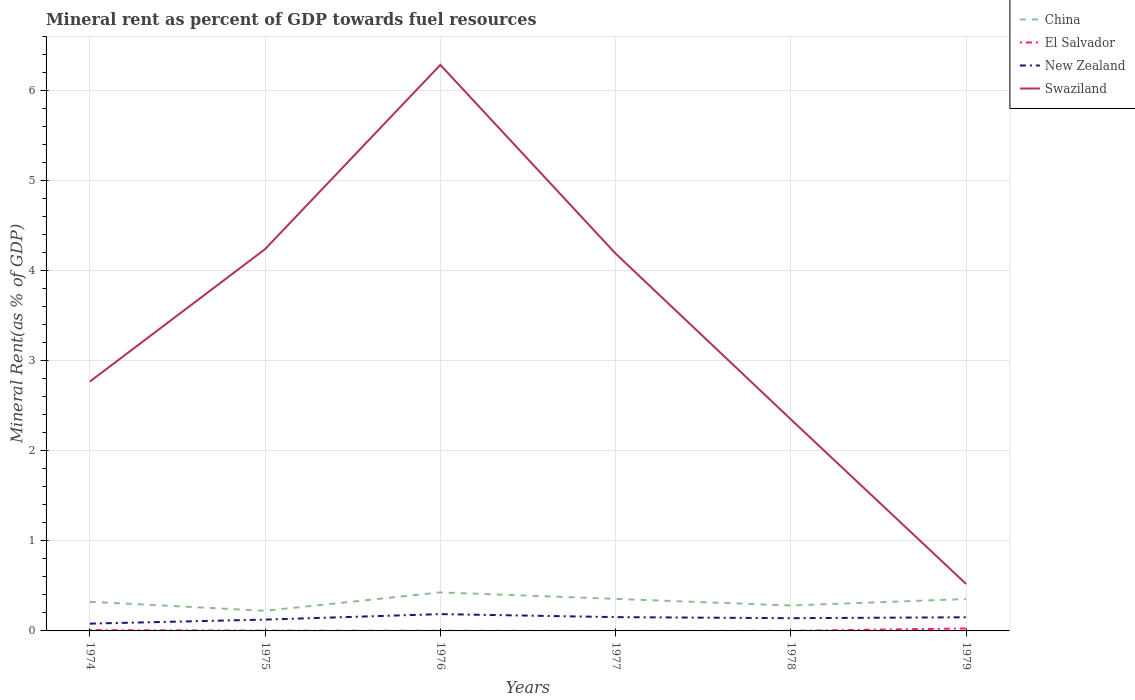How many different coloured lines are there?
Ensure brevity in your answer.  4. Is the number of lines equal to the number of legend labels?
Keep it short and to the point. Yes. Across all years, what is the maximum mineral rent in El Salvador?
Your response must be concise. 0. In which year was the mineral rent in New Zealand maximum?
Offer a terse response. 1974. What is the total mineral rent in El Salvador in the graph?
Your answer should be compact. 0.01. What is the difference between the highest and the second highest mineral rent in New Zealand?
Make the answer very short. 0.11. What is the difference between the highest and the lowest mineral rent in New Zealand?
Your answer should be compact. 4. How many lines are there?
Your response must be concise. 4. How many years are there in the graph?
Provide a succinct answer. 6. What is the difference between two consecutive major ticks on the Y-axis?
Provide a short and direct response. 1. Does the graph contain any zero values?
Your response must be concise. No. Does the graph contain grids?
Make the answer very short. Yes. What is the title of the graph?
Offer a very short reply. Mineral rent as percent of GDP towards fuel resources. Does "Latvia" appear as one of the legend labels in the graph?
Your answer should be very brief. No. What is the label or title of the Y-axis?
Give a very brief answer. Mineral Rent(as % of GDP). What is the Mineral Rent(as % of GDP) of China in 1974?
Offer a very short reply. 0.32. What is the Mineral Rent(as % of GDP) in El Salvador in 1974?
Offer a terse response. 0.01. What is the Mineral Rent(as % of GDP) of New Zealand in 1974?
Offer a terse response. 0.08. What is the Mineral Rent(as % of GDP) in Swaziland in 1974?
Ensure brevity in your answer.  2.77. What is the Mineral Rent(as % of GDP) of China in 1975?
Your answer should be very brief. 0.22. What is the Mineral Rent(as % of GDP) of El Salvador in 1975?
Give a very brief answer. 0. What is the Mineral Rent(as % of GDP) of New Zealand in 1975?
Your answer should be compact. 0.13. What is the Mineral Rent(as % of GDP) of Swaziland in 1975?
Offer a terse response. 4.24. What is the Mineral Rent(as % of GDP) of China in 1976?
Offer a terse response. 0.43. What is the Mineral Rent(as % of GDP) of El Salvador in 1976?
Provide a short and direct response. 0. What is the Mineral Rent(as % of GDP) of New Zealand in 1976?
Provide a short and direct response. 0.19. What is the Mineral Rent(as % of GDP) of Swaziland in 1976?
Provide a succinct answer. 6.29. What is the Mineral Rent(as % of GDP) in China in 1977?
Your answer should be very brief. 0.36. What is the Mineral Rent(as % of GDP) in El Salvador in 1977?
Provide a succinct answer. 0. What is the Mineral Rent(as % of GDP) of New Zealand in 1977?
Your answer should be very brief. 0.15. What is the Mineral Rent(as % of GDP) of Swaziland in 1977?
Keep it short and to the point. 4.19. What is the Mineral Rent(as % of GDP) of China in 1978?
Provide a succinct answer. 0.28. What is the Mineral Rent(as % of GDP) of El Salvador in 1978?
Offer a very short reply. 0. What is the Mineral Rent(as % of GDP) in New Zealand in 1978?
Make the answer very short. 0.14. What is the Mineral Rent(as % of GDP) of Swaziland in 1978?
Your answer should be very brief. 2.35. What is the Mineral Rent(as % of GDP) in China in 1979?
Offer a terse response. 0.35. What is the Mineral Rent(as % of GDP) in El Salvador in 1979?
Your answer should be compact. 0.03. What is the Mineral Rent(as % of GDP) in New Zealand in 1979?
Keep it short and to the point. 0.15. What is the Mineral Rent(as % of GDP) in Swaziland in 1979?
Ensure brevity in your answer.  0.52. Across all years, what is the maximum Mineral Rent(as % of GDP) in China?
Make the answer very short. 0.43. Across all years, what is the maximum Mineral Rent(as % of GDP) in El Salvador?
Make the answer very short. 0.03. Across all years, what is the maximum Mineral Rent(as % of GDP) in New Zealand?
Your response must be concise. 0.19. Across all years, what is the maximum Mineral Rent(as % of GDP) in Swaziland?
Ensure brevity in your answer.  6.29. Across all years, what is the minimum Mineral Rent(as % of GDP) in China?
Keep it short and to the point. 0.22. Across all years, what is the minimum Mineral Rent(as % of GDP) in El Salvador?
Provide a succinct answer. 0. Across all years, what is the minimum Mineral Rent(as % of GDP) of New Zealand?
Ensure brevity in your answer.  0.08. Across all years, what is the minimum Mineral Rent(as % of GDP) of Swaziland?
Make the answer very short. 0.52. What is the total Mineral Rent(as % of GDP) in China in the graph?
Your answer should be very brief. 1.97. What is the total Mineral Rent(as % of GDP) of El Salvador in the graph?
Make the answer very short. 0.04. What is the total Mineral Rent(as % of GDP) of New Zealand in the graph?
Give a very brief answer. 0.84. What is the total Mineral Rent(as % of GDP) of Swaziland in the graph?
Provide a short and direct response. 20.36. What is the difference between the Mineral Rent(as % of GDP) in China in 1974 and that in 1975?
Your response must be concise. 0.1. What is the difference between the Mineral Rent(as % of GDP) of El Salvador in 1974 and that in 1975?
Ensure brevity in your answer.  0.01. What is the difference between the Mineral Rent(as % of GDP) in New Zealand in 1974 and that in 1975?
Make the answer very short. -0.04. What is the difference between the Mineral Rent(as % of GDP) in Swaziland in 1974 and that in 1975?
Give a very brief answer. -1.47. What is the difference between the Mineral Rent(as % of GDP) in China in 1974 and that in 1976?
Your answer should be compact. -0.1. What is the difference between the Mineral Rent(as % of GDP) of El Salvador in 1974 and that in 1976?
Your answer should be very brief. 0.01. What is the difference between the Mineral Rent(as % of GDP) of New Zealand in 1974 and that in 1976?
Provide a succinct answer. -0.11. What is the difference between the Mineral Rent(as % of GDP) of Swaziland in 1974 and that in 1976?
Offer a very short reply. -3.52. What is the difference between the Mineral Rent(as % of GDP) of China in 1974 and that in 1977?
Make the answer very short. -0.03. What is the difference between the Mineral Rent(as % of GDP) of El Salvador in 1974 and that in 1977?
Offer a terse response. 0.01. What is the difference between the Mineral Rent(as % of GDP) of New Zealand in 1974 and that in 1977?
Provide a short and direct response. -0.07. What is the difference between the Mineral Rent(as % of GDP) of Swaziland in 1974 and that in 1977?
Offer a very short reply. -1.42. What is the difference between the Mineral Rent(as % of GDP) of China in 1974 and that in 1978?
Give a very brief answer. 0.04. What is the difference between the Mineral Rent(as % of GDP) of El Salvador in 1974 and that in 1978?
Keep it short and to the point. 0.01. What is the difference between the Mineral Rent(as % of GDP) of New Zealand in 1974 and that in 1978?
Provide a short and direct response. -0.06. What is the difference between the Mineral Rent(as % of GDP) in Swaziland in 1974 and that in 1978?
Provide a succinct answer. 0.42. What is the difference between the Mineral Rent(as % of GDP) of China in 1974 and that in 1979?
Ensure brevity in your answer.  -0.03. What is the difference between the Mineral Rent(as % of GDP) in El Salvador in 1974 and that in 1979?
Give a very brief answer. -0.02. What is the difference between the Mineral Rent(as % of GDP) of New Zealand in 1974 and that in 1979?
Your answer should be very brief. -0.07. What is the difference between the Mineral Rent(as % of GDP) in Swaziland in 1974 and that in 1979?
Offer a terse response. 2.25. What is the difference between the Mineral Rent(as % of GDP) of China in 1975 and that in 1976?
Provide a short and direct response. -0.2. What is the difference between the Mineral Rent(as % of GDP) in El Salvador in 1975 and that in 1976?
Your response must be concise. 0. What is the difference between the Mineral Rent(as % of GDP) of New Zealand in 1975 and that in 1976?
Your response must be concise. -0.06. What is the difference between the Mineral Rent(as % of GDP) of Swaziland in 1975 and that in 1976?
Offer a terse response. -2.05. What is the difference between the Mineral Rent(as % of GDP) in China in 1975 and that in 1977?
Your answer should be compact. -0.13. What is the difference between the Mineral Rent(as % of GDP) in El Salvador in 1975 and that in 1977?
Your answer should be compact. 0. What is the difference between the Mineral Rent(as % of GDP) of New Zealand in 1975 and that in 1977?
Offer a very short reply. -0.03. What is the difference between the Mineral Rent(as % of GDP) of Swaziland in 1975 and that in 1977?
Make the answer very short. 0.05. What is the difference between the Mineral Rent(as % of GDP) in China in 1975 and that in 1978?
Provide a short and direct response. -0.06. What is the difference between the Mineral Rent(as % of GDP) of El Salvador in 1975 and that in 1978?
Provide a succinct answer. 0. What is the difference between the Mineral Rent(as % of GDP) of New Zealand in 1975 and that in 1978?
Provide a short and direct response. -0.02. What is the difference between the Mineral Rent(as % of GDP) in Swaziland in 1975 and that in 1978?
Your answer should be compact. 1.89. What is the difference between the Mineral Rent(as % of GDP) in China in 1975 and that in 1979?
Provide a short and direct response. -0.13. What is the difference between the Mineral Rent(as % of GDP) of El Salvador in 1975 and that in 1979?
Offer a very short reply. -0.02. What is the difference between the Mineral Rent(as % of GDP) in New Zealand in 1975 and that in 1979?
Give a very brief answer. -0.03. What is the difference between the Mineral Rent(as % of GDP) of Swaziland in 1975 and that in 1979?
Offer a very short reply. 3.72. What is the difference between the Mineral Rent(as % of GDP) in China in 1976 and that in 1977?
Keep it short and to the point. 0.07. What is the difference between the Mineral Rent(as % of GDP) of El Salvador in 1976 and that in 1977?
Ensure brevity in your answer.  0. What is the difference between the Mineral Rent(as % of GDP) of New Zealand in 1976 and that in 1977?
Give a very brief answer. 0.03. What is the difference between the Mineral Rent(as % of GDP) of Swaziland in 1976 and that in 1977?
Your answer should be compact. 2.1. What is the difference between the Mineral Rent(as % of GDP) in China in 1976 and that in 1978?
Offer a terse response. 0.15. What is the difference between the Mineral Rent(as % of GDP) of New Zealand in 1976 and that in 1978?
Provide a short and direct response. 0.05. What is the difference between the Mineral Rent(as % of GDP) in Swaziland in 1976 and that in 1978?
Provide a succinct answer. 3.94. What is the difference between the Mineral Rent(as % of GDP) in China in 1976 and that in 1979?
Keep it short and to the point. 0.07. What is the difference between the Mineral Rent(as % of GDP) of El Salvador in 1976 and that in 1979?
Keep it short and to the point. -0.03. What is the difference between the Mineral Rent(as % of GDP) of New Zealand in 1976 and that in 1979?
Provide a succinct answer. 0.04. What is the difference between the Mineral Rent(as % of GDP) in Swaziland in 1976 and that in 1979?
Offer a very short reply. 5.76. What is the difference between the Mineral Rent(as % of GDP) of China in 1977 and that in 1978?
Offer a terse response. 0.07. What is the difference between the Mineral Rent(as % of GDP) of El Salvador in 1977 and that in 1978?
Provide a succinct answer. -0. What is the difference between the Mineral Rent(as % of GDP) of New Zealand in 1977 and that in 1978?
Provide a short and direct response. 0.01. What is the difference between the Mineral Rent(as % of GDP) in Swaziland in 1977 and that in 1978?
Provide a short and direct response. 1.84. What is the difference between the Mineral Rent(as % of GDP) of China in 1977 and that in 1979?
Ensure brevity in your answer.  0. What is the difference between the Mineral Rent(as % of GDP) of El Salvador in 1977 and that in 1979?
Your answer should be compact. -0.03. What is the difference between the Mineral Rent(as % of GDP) of New Zealand in 1977 and that in 1979?
Provide a succinct answer. 0. What is the difference between the Mineral Rent(as % of GDP) in Swaziland in 1977 and that in 1979?
Keep it short and to the point. 3.67. What is the difference between the Mineral Rent(as % of GDP) in China in 1978 and that in 1979?
Keep it short and to the point. -0.07. What is the difference between the Mineral Rent(as % of GDP) in El Salvador in 1978 and that in 1979?
Offer a terse response. -0.03. What is the difference between the Mineral Rent(as % of GDP) in New Zealand in 1978 and that in 1979?
Keep it short and to the point. -0.01. What is the difference between the Mineral Rent(as % of GDP) in Swaziland in 1978 and that in 1979?
Ensure brevity in your answer.  1.83. What is the difference between the Mineral Rent(as % of GDP) in China in 1974 and the Mineral Rent(as % of GDP) in El Salvador in 1975?
Provide a short and direct response. 0.32. What is the difference between the Mineral Rent(as % of GDP) of China in 1974 and the Mineral Rent(as % of GDP) of New Zealand in 1975?
Your answer should be compact. 0.2. What is the difference between the Mineral Rent(as % of GDP) in China in 1974 and the Mineral Rent(as % of GDP) in Swaziland in 1975?
Your answer should be compact. -3.92. What is the difference between the Mineral Rent(as % of GDP) in El Salvador in 1974 and the Mineral Rent(as % of GDP) in New Zealand in 1975?
Give a very brief answer. -0.12. What is the difference between the Mineral Rent(as % of GDP) in El Salvador in 1974 and the Mineral Rent(as % of GDP) in Swaziland in 1975?
Ensure brevity in your answer.  -4.23. What is the difference between the Mineral Rent(as % of GDP) in New Zealand in 1974 and the Mineral Rent(as % of GDP) in Swaziland in 1975?
Provide a short and direct response. -4.16. What is the difference between the Mineral Rent(as % of GDP) of China in 1974 and the Mineral Rent(as % of GDP) of El Salvador in 1976?
Your answer should be very brief. 0.32. What is the difference between the Mineral Rent(as % of GDP) of China in 1974 and the Mineral Rent(as % of GDP) of New Zealand in 1976?
Your answer should be compact. 0.14. What is the difference between the Mineral Rent(as % of GDP) of China in 1974 and the Mineral Rent(as % of GDP) of Swaziland in 1976?
Keep it short and to the point. -5.96. What is the difference between the Mineral Rent(as % of GDP) in El Salvador in 1974 and the Mineral Rent(as % of GDP) in New Zealand in 1976?
Keep it short and to the point. -0.18. What is the difference between the Mineral Rent(as % of GDP) of El Salvador in 1974 and the Mineral Rent(as % of GDP) of Swaziland in 1976?
Offer a terse response. -6.28. What is the difference between the Mineral Rent(as % of GDP) of New Zealand in 1974 and the Mineral Rent(as % of GDP) of Swaziland in 1976?
Offer a very short reply. -6.21. What is the difference between the Mineral Rent(as % of GDP) of China in 1974 and the Mineral Rent(as % of GDP) of El Salvador in 1977?
Provide a succinct answer. 0.32. What is the difference between the Mineral Rent(as % of GDP) of China in 1974 and the Mineral Rent(as % of GDP) of New Zealand in 1977?
Ensure brevity in your answer.  0.17. What is the difference between the Mineral Rent(as % of GDP) of China in 1974 and the Mineral Rent(as % of GDP) of Swaziland in 1977?
Your answer should be compact. -3.87. What is the difference between the Mineral Rent(as % of GDP) in El Salvador in 1974 and the Mineral Rent(as % of GDP) in New Zealand in 1977?
Provide a short and direct response. -0.14. What is the difference between the Mineral Rent(as % of GDP) in El Salvador in 1974 and the Mineral Rent(as % of GDP) in Swaziland in 1977?
Offer a terse response. -4.18. What is the difference between the Mineral Rent(as % of GDP) of New Zealand in 1974 and the Mineral Rent(as % of GDP) of Swaziland in 1977?
Offer a very short reply. -4.11. What is the difference between the Mineral Rent(as % of GDP) of China in 1974 and the Mineral Rent(as % of GDP) of El Salvador in 1978?
Make the answer very short. 0.32. What is the difference between the Mineral Rent(as % of GDP) in China in 1974 and the Mineral Rent(as % of GDP) in New Zealand in 1978?
Provide a succinct answer. 0.18. What is the difference between the Mineral Rent(as % of GDP) of China in 1974 and the Mineral Rent(as % of GDP) of Swaziland in 1978?
Give a very brief answer. -2.03. What is the difference between the Mineral Rent(as % of GDP) of El Salvador in 1974 and the Mineral Rent(as % of GDP) of New Zealand in 1978?
Provide a short and direct response. -0.13. What is the difference between the Mineral Rent(as % of GDP) in El Salvador in 1974 and the Mineral Rent(as % of GDP) in Swaziland in 1978?
Your answer should be very brief. -2.34. What is the difference between the Mineral Rent(as % of GDP) of New Zealand in 1974 and the Mineral Rent(as % of GDP) of Swaziland in 1978?
Ensure brevity in your answer.  -2.27. What is the difference between the Mineral Rent(as % of GDP) of China in 1974 and the Mineral Rent(as % of GDP) of El Salvador in 1979?
Make the answer very short. 0.3. What is the difference between the Mineral Rent(as % of GDP) in China in 1974 and the Mineral Rent(as % of GDP) in New Zealand in 1979?
Provide a succinct answer. 0.17. What is the difference between the Mineral Rent(as % of GDP) in China in 1974 and the Mineral Rent(as % of GDP) in Swaziland in 1979?
Make the answer very short. -0.2. What is the difference between the Mineral Rent(as % of GDP) in El Salvador in 1974 and the Mineral Rent(as % of GDP) in New Zealand in 1979?
Offer a terse response. -0.14. What is the difference between the Mineral Rent(as % of GDP) of El Salvador in 1974 and the Mineral Rent(as % of GDP) of Swaziland in 1979?
Offer a terse response. -0.51. What is the difference between the Mineral Rent(as % of GDP) in New Zealand in 1974 and the Mineral Rent(as % of GDP) in Swaziland in 1979?
Your answer should be compact. -0.44. What is the difference between the Mineral Rent(as % of GDP) of China in 1975 and the Mineral Rent(as % of GDP) of El Salvador in 1976?
Offer a very short reply. 0.22. What is the difference between the Mineral Rent(as % of GDP) of China in 1975 and the Mineral Rent(as % of GDP) of New Zealand in 1976?
Offer a terse response. 0.04. What is the difference between the Mineral Rent(as % of GDP) of China in 1975 and the Mineral Rent(as % of GDP) of Swaziland in 1976?
Offer a very short reply. -6.06. What is the difference between the Mineral Rent(as % of GDP) in El Salvador in 1975 and the Mineral Rent(as % of GDP) in New Zealand in 1976?
Your response must be concise. -0.18. What is the difference between the Mineral Rent(as % of GDP) in El Salvador in 1975 and the Mineral Rent(as % of GDP) in Swaziland in 1976?
Give a very brief answer. -6.28. What is the difference between the Mineral Rent(as % of GDP) of New Zealand in 1975 and the Mineral Rent(as % of GDP) of Swaziland in 1976?
Offer a very short reply. -6.16. What is the difference between the Mineral Rent(as % of GDP) in China in 1975 and the Mineral Rent(as % of GDP) in El Salvador in 1977?
Make the answer very short. 0.22. What is the difference between the Mineral Rent(as % of GDP) of China in 1975 and the Mineral Rent(as % of GDP) of New Zealand in 1977?
Your answer should be compact. 0.07. What is the difference between the Mineral Rent(as % of GDP) in China in 1975 and the Mineral Rent(as % of GDP) in Swaziland in 1977?
Ensure brevity in your answer.  -3.97. What is the difference between the Mineral Rent(as % of GDP) of El Salvador in 1975 and the Mineral Rent(as % of GDP) of New Zealand in 1977?
Your response must be concise. -0.15. What is the difference between the Mineral Rent(as % of GDP) in El Salvador in 1975 and the Mineral Rent(as % of GDP) in Swaziland in 1977?
Your answer should be compact. -4.19. What is the difference between the Mineral Rent(as % of GDP) of New Zealand in 1975 and the Mineral Rent(as % of GDP) of Swaziland in 1977?
Your answer should be very brief. -4.06. What is the difference between the Mineral Rent(as % of GDP) in China in 1975 and the Mineral Rent(as % of GDP) in El Salvador in 1978?
Give a very brief answer. 0.22. What is the difference between the Mineral Rent(as % of GDP) in China in 1975 and the Mineral Rent(as % of GDP) in New Zealand in 1978?
Offer a terse response. 0.08. What is the difference between the Mineral Rent(as % of GDP) of China in 1975 and the Mineral Rent(as % of GDP) of Swaziland in 1978?
Your answer should be very brief. -2.13. What is the difference between the Mineral Rent(as % of GDP) in El Salvador in 1975 and the Mineral Rent(as % of GDP) in New Zealand in 1978?
Your response must be concise. -0.14. What is the difference between the Mineral Rent(as % of GDP) of El Salvador in 1975 and the Mineral Rent(as % of GDP) of Swaziland in 1978?
Keep it short and to the point. -2.35. What is the difference between the Mineral Rent(as % of GDP) of New Zealand in 1975 and the Mineral Rent(as % of GDP) of Swaziland in 1978?
Your answer should be very brief. -2.22. What is the difference between the Mineral Rent(as % of GDP) in China in 1975 and the Mineral Rent(as % of GDP) in El Salvador in 1979?
Offer a terse response. 0.2. What is the difference between the Mineral Rent(as % of GDP) of China in 1975 and the Mineral Rent(as % of GDP) of New Zealand in 1979?
Keep it short and to the point. 0.07. What is the difference between the Mineral Rent(as % of GDP) in China in 1975 and the Mineral Rent(as % of GDP) in Swaziland in 1979?
Your answer should be compact. -0.3. What is the difference between the Mineral Rent(as % of GDP) in El Salvador in 1975 and the Mineral Rent(as % of GDP) in New Zealand in 1979?
Offer a very short reply. -0.15. What is the difference between the Mineral Rent(as % of GDP) of El Salvador in 1975 and the Mineral Rent(as % of GDP) of Swaziland in 1979?
Offer a very short reply. -0.52. What is the difference between the Mineral Rent(as % of GDP) of New Zealand in 1975 and the Mineral Rent(as % of GDP) of Swaziland in 1979?
Make the answer very short. -0.4. What is the difference between the Mineral Rent(as % of GDP) in China in 1976 and the Mineral Rent(as % of GDP) in El Salvador in 1977?
Provide a short and direct response. 0.43. What is the difference between the Mineral Rent(as % of GDP) in China in 1976 and the Mineral Rent(as % of GDP) in New Zealand in 1977?
Offer a very short reply. 0.27. What is the difference between the Mineral Rent(as % of GDP) of China in 1976 and the Mineral Rent(as % of GDP) of Swaziland in 1977?
Make the answer very short. -3.76. What is the difference between the Mineral Rent(as % of GDP) in El Salvador in 1976 and the Mineral Rent(as % of GDP) in New Zealand in 1977?
Make the answer very short. -0.15. What is the difference between the Mineral Rent(as % of GDP) in El Salvador in 1976 and the Mineral Rent(as % of GDP) in Swaziland in 1977?
Keep it short and to the point. -4.19. What is the difference between the Mineral Rent(as % of GDP) in New Zealand in 1976 and the Mineral Rent(as % of GDP) in Swaziland in 1977?
Your answer should be compact. -4. What is the difference between the Mineral Rent(as % of GDP) in China in 1976 and the Mineral Rent(as % of GDP) in El Salvador in 1978?
Give a very brief answer. 0.43. What is the difference between the Mineral Rent(as % of GDP) in China in 1976 and the Mineral Rent(as % of GDP) in New Zealand in 1978?
Your response must be concise. 0.29. What is the difference between the Mineral Rent(as % of GDP) of China in 1976 and the Mineral Rent(as % of GDP) of Swaziland in 1978?
Offer a terse response. -1.92. What is the difference between the Mineral Rent(as % of GDP) of El Salvador in 1976 and the Mineral Rent(as % of GDP) of New Zealand in 1978?
Your answer should be compact. -0.14. What is the difference between the Mineral Rent(as % of GDP) in El Salvador in 1976 and the Mineral Rent(as % of GDP) in Swaziland in 1978?
Give a very brief answer. -2.35. What is the difference between the Mineral Rent(as % of GDP) in New Zealand in 1976 and the Mineral Rent(as % of GDP) in Swaziland in 1978?
Give a very brief answer. -2.16. What is the difference between the Mineral Rent(as % of GDP) in China in 1976 and the Mineral Rent(as % of GDP) in El Salvador in 1979?
Keep it short and to the point. 0.4. What is the difference between the Mineral Rent(as % of GDP) in China in 1976 and the Mineral Rent(as % of GDP) in New Zealand in 1979?
Offer a very short reply. 0.28. What is the difference between the Mineral Rent(as % of GDP) of China in 1976 and the Mineral Rent(as % of GDP) of Swaziland in 1979?
Provide a succinct answer. -0.09. What is the difference between the Mineral Rent(as % of GDP) in El Salvador in 1976 and the Mineral Rent(as % of GDP) in New Zealand in 1979?
Provide a short and direct response. -0.15. What is the difference between the Mineral Rent(as % of GDP) in El Salvador in 1976 and the Mineral Rent(as % of GDP) in Swaziland in 1979?
Provide a succinct answer. -0.52. What is the difference between the Mineral Rent(as % of GDP) in New Zealand in 1976 and the Mineral Rent(as % of GDP) in Swaziland in 1979?
Offer a terse response. -0.34. What is the difference between the Mineral Rent(as % of GDP) of China in 1977 and the Mineral Rent(as % of GDP) of El Salvador in 1978?
Offer a terse response. 0.35. What is the difference between the Mineral Rent(as % of GDP) of China in 1977 and the Mineral Rent(as % of GDP) of New Zealand in 1978?
Provide a short and direct response. 0.21. What is the difference between the Mineral Rent(as % of GDP) of China in 1977 and the Mineral Rent(as % of GDP) of Swaziland in 1978?
Your answer should be compact. -1.99. What is the difference between the Mineral Rent(as % of GDP) of El Salvador in 1977 and the Mineral Rent(as % of GDP) of New Zealand in 1978?
Keep it short and to the point. -0.14. What is the difference between the Mineral Rent(as % of GDP) of El Salvador in 1977 and the Mineral Rent(as % of GDP) of Swaziland in 1978?
Give a very brief answer. -2.35. What is the difference between the Mineral Rent(as % of GDP) of New Zealand in 1977 and the Mineral Rent(as % of GDP) of Swaziland in 1978?
Provide a short and direct response. -2.2. What is the difference between the Mineral Rent(as % of GDP) in China in 1977 and the Mineral Rent(as % of GDP) in El Salvador in 1979?
Offer a very short reply. 0.33. What is the difference between the Mineral Rent(as % of GDP) of China in 1977 and the Mineral Rent(as % of GDP) of New Zealand in 1979?
Your response must be concise. 0.2. What is the difference between the Mineral Rent(as % of GDP) of China in 1977 and the Mineral Rent(as % of GDP) of Swaziland in 1979?
Provide a short and direct response. -0.17. What is the difference between the Mineral Rent(as % of GDP) of El Salvador in 1977 and the Mineral Rent(as % of GDP) of New Zealand in 1979?
Make the answer very short. -0.15. What is the difference between the Mineral Rent(as % of GDP) in El Salvador in 1977 and the Mineral Rent(as % of GDP) in Swaziland in 1979?
Your answer should be compact. -0.52. What is the difference between the Mineral Rent(as % of GDP) in New Zealand in 1977 and the Mineral Rent(as % of GDP) in Swaziland in 1979?
Provide a short and direct response. -0.37. What is the difference between the Mineral Rent(as % of GDP) of China in 1978 and the Mineral Rent(as % of GDP) of El Salvador in 1979?
Make the answer very short. 0.25. What is the difference between the Mineral Rent(as % of GDP) in China in 1978 and the Mineral Rent(as % of GDP) in New Zealand in 1979?
Keep it short and to the point. 0.13. What is the difference between the Mineral Rent(as % of GDP) in China in 1978 and the Mineral Rent(as % of GDP) in Swaziland in 1979?
Offer a very short reply. -0.24. What is the difference between the Mineral Rent(as % of GDP) in El Salvador in 1978 and the Mineral Rent(as % of GDP) in New Zealand in 1979?
Provide a succinct answer. -0.15. What is the difference between the Mineral Rent(as % of GDP) in El Salvador in 1978 and the Mineral Rent(as % of GDP) in Swaziland in 1979?
Provide a short and direct response. -0.52. What is the difference between the Mineral Rent(as % of GDP) of New Zealand in 1978 and the Mineral Rent(as % of GDP) of Swaziland in 1979?
Give a very brief answer. -0.38. What is the average Mineral Rent(as % of GDP) of China per year?
Make the answer very short. 0.33. What is the average Mineral Rent(as % of GDP) in El Salvador per year?
Make the answer very short. 0.01. What is the average Mineral Rent(as % of GDP) in New Zealand per year?
Give a very brief answer. 0.14. What is the average Mineral Rent(as % of GDP) of Swaziland per year?
Your answer should be very brief. 3.39. In the year 1974, what is the difference between the Mineral Rent(as % of GDP) in China and Mineral Rent(as % of GDP) in El Salvador?
Your answer should be very brief. 0.31. In the year 1974, what is the difference between the Mineral Rent(as % of GDP) of China and Mineral Rent(as % of GDP) of New Zealand?
Keep it short and to the point. 0.24. In the year 1974, what is the difference between the Mineral Rent(as % of GDP) of China and Mineral Rent(as % of GDP) of Swaziland?
Your answer should be very brief. -2.45. In the year 1974, what is the difference between the Mineral Rent(as % of GDP) of El Salvador and Mineral Rent(as % of GDP) of New Zealand?
Offer a very short reply. -0.07. In the year 1974, what is the difference between the Mineral Rent(as % of GDP) of El Salvador and Mineral Rent(as % of GDP) of Swaziland?
Make the answer very short. -2.76. In the year 1974, what is the difference between the Mineral Rent(as % of GDP) in New Zealand and Mineral Rent(as % of GDP) in Swaziland?
Give a very brief answer. -2.69. In the year 1975, what is the difference between the Mineral Rent(as % of GDP) in China and Mineral Rent(as % of GDP) in El Salvador?
Make the answer very short. 0.22. In the year 1975, what is the difference between the Mineral Rent(as % of GDP) of China and Mineral Rent(as % of GDP) of New Zealand?
Keep it short and to the point. 0.1. In the year 1975, what is the difference between the Mineral Rent(as % of GDP) of China and Mineral Rent(as % of GDP) of Swaziland?
Your answer should be very brief. -4.02. In the year 1975, what is the difference between the Mineral Rent(as % of GDP) in El Salvador and Mineral Rent(as % of GDP) in New Zealand?
Give a very brief answer. -0.12. In the year 1975, what is the difference between the Mineral Rent(as % of GDP) of El Salvador and Mineral Rent(as % of GDP) of Swaziland?
Give a very brief answer. -4.24. In the year 1975, what is the difference between the Mineral Rent(as % of GDP) of New Zealand and Mineral Rent(as % of GDP) of Swaziland?
Your answer should be very brief. -4.11. In the year 1976, what is the difference between the Mineral Rent(as % of GDP) of China and Mineral Rent(as % of GDP) of El Salvador?
Keep it short and to the point. 0.43. In the year 1976, what is the difference between the Mineral Rent(as % of GDP) in China and Mineral Rent(as % of GDP) in New Zealand?
Your answer should be compact. 0.24. In the year 1976, what is the difference between the Mineral Rent(as % of GDP) of China and Mineral Rent(as % of GDP) of Swaziland?
Provide a short and direct response. -5.86. In the year 1976, what is the difference between the Mineral Rent(as % of GDP) in El Salvador and Mineral Rent(as % of GDP) in New Zealand?
Provide a succinct answer. -0.19. In the year 1976, what is the difference between the Mineral Rent(as % of GDP) in El Salvador and Mineral Rent(as % of GDP) in Swaziland?
Provide a succinct answer. -6.29. In the year 1976, what is the difference between the Mineral Rent(as % of GDP) of New Zealand and Mineral Rent(as % of GDP) of Swaziland?
Give a very brief answer. -6.1. In the year 1977, what is the difference between the Mineral Rent(as % of GDP) in China and Mineral Rent(as % of GDP) in El Salvador?
Your response must be concise. 0.36. In the year 1977, what is the difference between the Mineral Rent(as % of GDP) in China and Mineral Rent(as % of GDP) in New Zealand?
Make the answer very short. 0.2. In the year 1977, what is the difference between the Mineral Rent(as % of GDP) of China and Mineral Rent(as % of GDP) of Swaziland?
Make the answer very short. -3.83. In the year 1977, what is the difference between the Mineral Rent(as % of GDP) of El Salvador and Mineral Rent(as % of GDP) of New Zealand?
Your answer should be compact. -0.15. In the year 1977, what is the difference between the Mineral Rent(as % of GDP) in El Salvador and Mineral Rent(as % of GDP) in Swaziland?
Offer a very short reply. -4.19. In the year 1977, what is the difference between the Mineral Rent(as % of GDP) in New Zealand and Mineral Rent(as % of GDP) in Swaziland?
Your answer should be compact. -4.04. In the year 1978, what is the difference between the Mineral Rent(as % of GDP) in China and Mineral Rent(as % of GDP) in El Salvador?
Give a very brief answer. 0.28. In the year 1978, what is the difference between the Mineral Rent(as % of GDP) of China and Mineral Rent(as % of GDP) of New Zealand?
Your answer should be very brief. 0.14. In the year 1978, what is the difference between the Mineral Rent(as % of GDP) of China and Mineral Rent(as % of GDP) of Swaziland?
Offer a terse response. -2.07. In the year 1978, what is the difference between the Mineral Rent(as % of GDP) in El Salvador and Mineral Rent(as % of GDP) in New Zealand?
Give a very brief answer. -0.14. In the year 1978, what is the difference between the Mineral Rent(as % of GDP) of El Salvador and Mineral Rent(as % of GDP) of Swaziland?
Provide a short and direct response. -2.35. In the year 1978, what is the difference between the Mineral Rent(as % of GDP) in New Zealand and Mineral Rent(as % of GDP) in Swaziland?
Provide a short and direct response. -2.21. In the year 1979, what is the difference between the Mineral Rent(as % of GDP) of China and Mineral Rent(as % of GDP) of El Salvador?
Offer a very short reply. 0.33. In the year 1979, what is the difference between the Mineral Rent(as % of GDP) in China and Mineral Rent(as % of GDP) in New Zealand?
Your response must be concise. 0.2. In the year 1979, what is the difference between the Mineral Rent(as % of GDP) in China and Mineral Rent(as % of GDP) in Swaziland?
Your response must be concise. -0.17. In the year 1979, what is the difference between the Mineral Rent(as % of GDP) of El Salvador and Mineral Rent(as % of GDP) of New Zealand?
Provide a succinct answer. -0.12. In the year 1979, what is the difference between the Mineral Rent(as % of GDP) in El Salvador and Mineral Rent(as % of GDP) in Swaziland?
Give a very brief answer. -0.49. In the year 1979, what is the difference between the Mineral Rent(as % of GDP) of New Zealand and Mineral Rent(as % of GDP) of Swaziland?
Your answer should be compact. -0.37. What is the ratio of the Mineral Rent(as % of GDP) in China in 1974 to that in 1975?
Keep it short and to the point. 1.45. What is the ratio of the Mineral Rent(as % of GDP) of El Salvador in 1974 to that in 1975?
Keep it short and to the point. 3.37. What is the ratio of the Mineral Rent(as % of GDP) of New Zealand in 1974 to that in 1975?
Offer a terse response. 0.64. What is the ratio of the Mineral Rent(as % of GDP) in Swaziland in 1974 to that in 1975?
Offer a very short reply. 0.65. What is the ratio of the Mineral Rent(as % of GDP) of China in 1974 to that in 1976?
Your answer should be compact. 0.76. What is the ratio of the Mineral Rent(as % of GDP) in El Salvador in 1974 to that in 1976?
Your answer should be very brief. 8.59. What is the ratio of the Mineral Rent(as % of GDP) of New Zealand in 1974 to that in 1976?
Provide a succinct answer. 0.43. What is the ratio of the Mineral Rent(as % of GDP) in Swaziland in 1974 to that in 1976?
Your response must be concise. 0.44. What is the ratio of the Mineral Rent(as % of GDP) of China in 1974 to that in 1977?
Keep it short and to the point. 0.91. What is the ratio of the Mineral Rent(as % of GDP) in El Salvador in 1974 to that in 1977?
Your answer should be very brief. 28.91. What is the ratio of the Mineral Rent(as % of GDP) in New Zealand in 1974 to that in 1977?
Give a very brief answer. 0.53. What is the ratio of the Mineral Rent(as % of GDP) in Swaziland in 1974 to that in 1977?
Ensure brevity in your answer.  0.66. What is the ratio of the Mineral Rent(as % of GDP) of China in 1974 to that in 1978?
Offer a terse response. 1.15. What is the ratio of the Mineral Rent(as % of GDP) of El Salvador in 1974 to that in 1978?
Your response must be concise. 10.42. What is the ratio of the Mineral Rent(as % of GDP) of New Zealand in 1974 to that in 1978?
Your answer should be very brief. 0.57. What is the ratio of the Mineral Rent(as % of GDP) of Swaziland in 1974 to that in 1978?
Offer a very short reply. 1.18. What is the ratio of the Mineral Rent(as % of GDP) in China in 1974 to that in 1979?
Your response must be concise. 0.91. What is the ratio of the Mineral Rent(as % of GDP) of El Salvador in 1974 to that in 1979?
Give a very brief answer. 0.34. What is the ratio of the Mineral Rent(as % of GDP) in New Zealand in 1974 to that in 1979?
Your answer should be very brief. 0.53. What is the ratio of the Mineral Rent(as % of GDP) in Swaziland in 1974 to that in 1979?
Give a very brief answer. 5.31. What is the ratio of the Mineral Rent(as % of GDP) of China in 1975 to that in 1976?
Keep it short and to the point. 0.52. What is the ratio of the Mineral Rent(as % of GDP) in El Salvador in 1975 to that in 1976?
Provide a short and direct response. 2.55. What is the ratio of the Mineral Rent(as % of GDP) in New Zealand in 1975 to that in 1976?
Keep it short and to the point. 0.67. What is the ratio of the Mineral Rent(as % of GDP) in Swaziland in 1975 to that in 1976?
Give a very brief answer. 0.67. What is the ratio of the Mineral Rent(as % of GDP) of China in 1975 to that in 1977?
Offer a terse response. 0.63. What is the ratio of the Mineral Rent(as % of GDP) in El Salvador in 1975 to that in 1977?
Offer a very short reply. 8.57. What is the ratio of the Mineral Rent(as % of GDP) in New Zealand in 1975 to that in 1977?
Provide a succinct answer. 0.82. What is the ratio of the Mineral Rent(as % of GDP) in Swaziland in 1975 to that in 1977?
Keep it short and to the point. 1.01. What is the ratio of the Mineral Rent(as % of GDP) in China in 1975 to that in 1978?
Offer a terse response. 0.79. What is the ratio of the Mineral Rent(as % of GDP) of El Salvador in 1975 to that in 1978?
Provide a short and direct response. 3.09. What is the ratio of the Mineral Rent(as % of GDP) in New Zealand in 1975 to that in 1978?
Your response must be concise. 0.89. What is the ratio of the Mineral Rent(as % of GDP) in Swaziland in 1975 to that in 1978?
Provide a short and direct response. 1.8. What is the ratio of the Mineral Rent(as % of GDP) in China in 1975 to that in 1979?
Provide a short and direct response. 0.63. What is the ratio of the Mineral Rent(as % of GDP) of El Salvador in 1975 to that in 1979?
Offer a terse response. 0.1. What is the ratio of the Mineral Rent(as % of GDP) in New Zealand in 1975 to that in 1979?
Provide a succinct answer. 0.83. What is the ratio of the Mineral Rent(as % of GDP) in Swaziland in 1975 to that in 1979?
Provide a short and direct response. 8.13. What is the ratio of the Mineral Rent(as % of GDP) in China in 1976 to that in 1977?
Offer a terse response. 1.2. What is the ratio of the Mineral Rent(as % of GDP) in El Salvador in 1976 to that in 1977?
Offer a very short reply. 3.37. What is the ratio of the Mineral Rent(as % of GDP) of New Zealand in 1976 to that in 1977?
Offer a terse response. 1.22. What is the ratio of the Mineral Rent(as % of GDP) in Swaziland in 1976 to that in 1977?
Give a very brief answer. 1.5. What is the ratio of the Mineral Rent(as % of GDP) of China in 1976 to that in 1978?
Offer a very short reply. 1.51. What is the ratio of the Mineral Rent(as % of GDP) in El Salvador in 1976 to that in 1978?
Your answer should be very brief. 1.21. What is the ratio of the Mineral Rent(as % of GDP) of New Zealand in 1976 to that in 1978?
Your answer should be compact. 1.32. What is the ratio of the Mineral Rent(as % of GDP) in Swaziland in 1976 to that in 1978?
Keep it short and to the point. 2.68. What is the ratio of the Mineral Rent(as % of GDP) in China in 1976 to that in 1979?
Keep it short and to the point. 1.21. What is the ratio of the Mineral Rent(as % of GDP) in El Salvador in 1976 to that in 1979?
Give a very brief answer. 0.04. What is the ratio of the Mineral Rent(as % of GDP) in New Zealand in 1976 to that in 1979?
Your answer should be compact. 1.23. What is the ratio of the Mineral Rent(as % of GDP) in Swaziland in 1976 to that in 1979?
Provide a succinct answer. 12.05. What is the ratio of the Mineral Rent(as % of GDP) in China in 1977 to that in 1978?
Your response must be concise. 1.26. What is the ratio of the Mineral Rent(as % of GDP) in El Salvador in 1977 to that in 1978?
Keep it short and to the point. 0.36. What is the ratio of the Mineral Rent(as % of GDP) in New Zealand in 1977 to that in 1978?
Ensure brevity in your answer.  1.08. What is the ratio of the Mineral Rent(as % of GDP) of Swaziland in 1977 to that in 1978?
Your answer should be very brief. 1.78. What is the ratio of the Mineral Rent(as % of GDP) of El Salvador in 1977 to that in 1979?
Provide a succinct answer. 0.01. What is the ratio of the Mineral Rent(as % of GDP) of Swaziland in 1977 to that in 1979?
Make the answer very short. 8.03. What is the ratio of the Mineral Rent(as % of GDP) of China in 1978 to that in 1979?
Give a very brief answer. 0.8. What is the ratio of the Mineral Rent(as % of GDP) in El Salvador in 1978 to that in 1979?
Give a very brief answer. 0.03. What is the ratio of the Mineral Rent(as % of GDP) in New Zealand in 1978 to that in 1979?
Your response must be concise. 0.93. What is the ratio of the Mineral Rent(as % of GDP) in Swaziland in 1978 to that in 1979?
Ensure brevity in your answer.  4.5. What is the difference between the highest and the second highest Mineral Rent(as % of GDP) in China?
Provide a succinct answer. 0.07. What is the difference between the highest and the second highest Mineral Rent(as % of GDP) of El Salvador?
Give a very brief answer. 0.02. What is the difference between the highest and the second highest Mineral Rent(as % of GDP) of New Zealand?
Offer a terse response. 0.03. What is the difference between the highest and the second highest Mineral Rent(as % of GDP) in Swaziland?
Provide a succinct answer. 2.05. What is the difference between the highest and the lowest Mineral Rent(as % of GDP) of China?
Your answer should be compact. 0.2. What is the difference between the highest and the lowest Mineral Rent(as % of GDP) in El Salvador?
Give a very brief answer. 0.03. What is the difference between the highest and the lowest Mineral Rent(as % of GDP) in New Zealand?
Offer a terse response. 0.11. What is the difference between the highest and the lowest Mineral Rent(as % of GDP) in Swaziland?
Your response must be concise. 5.76. 